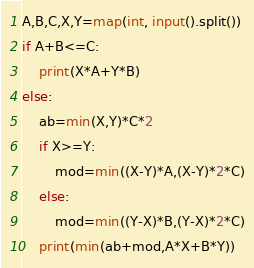Convert code to text. <code><loc_0><loc_0><loc_500><loc_500><_Python_>A,B,C,X,Y=map(int, input().split())
if A+B<=C:
    print(X*A+Y*B)
else:
    ab=min(X,Y)*C*2
    if X>=Y:
        mod=min((X-Y)*A,(X-Y)*2*C)
    else:
        mod=min((Y-X)*B,(Y-X)*2*C)
    print(min(ab+mod,A*X+B*Y))</code> 